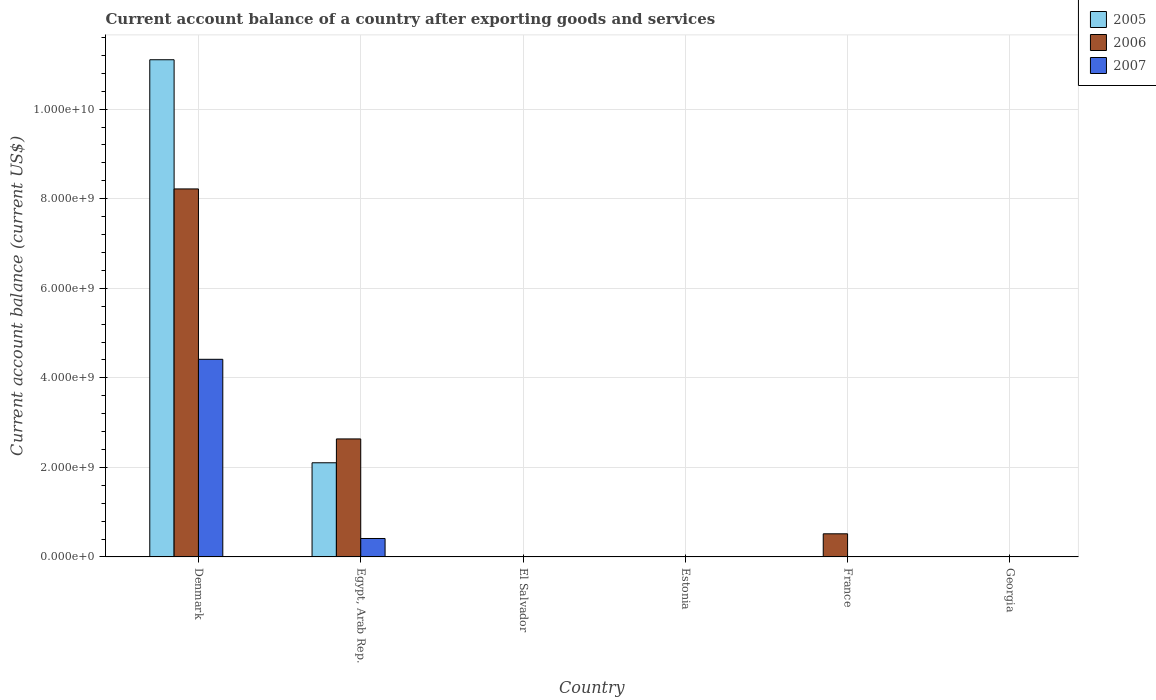What is the label of the 2nd group of bars from the left?
Your answer should be very brief. Egypt, Arab Rep. What is the account balance in 2006 in France?
Offer a terse response. 5.16e+08. Across all countries, what is the maximum account balance in 2007?
Provide a succinct answer. 4.41e+09. What is the total account balance in 2005 in the graph?
Keep it short and to the point. 1.32e+1. What is the difference between the account balance in 2007 in Denmark and that in Egypt, Arab Rep.?
Offer a terse response. 4.00e+09. What is the average account balance in 2007 per country?
Provide a succinct answer. 8.04e+08. What is the difference between the account balance of/in 2006 and account balance of/in 2005 in Denmark?
Offer a very short reply. -2.89e+09. What is the ratio of the account balance in 2005 in Denmark to that in Egypt, Arab Rep.?
Keep it short and to the point. 5.28. What is the difference between the highest and the second highest account balance in 2006?
Your response must be concise. 2.12e+09. What is the difference between the highest and the lowest account balance in 2006?
Your answer should be very brief. 8.22e+09. In how many countries, is the account balance in 2006 greater than the average account balance in 2006 taken over all countries?
Provide a succinct answer. 2. How many bars are there?
Ensure brevity in your answer.  7. Are all the bars in the graph horizontal?
Make the answer very short. No. What is the difference between two consecutive major ticks on the Y-axis?
Ensure brevity in your answer.  2.00e+09. Does the graph contain grids?
Give a very brief answer. Yes. Where does the legend appear in the graph?
Your answer should be very brief. Top right. What is the title of the graph?
Offer a very short reply. Current account balance of a country after exporting goods and services. What is the label or title of the Y-axis?
Your response must be concise. Current account balance (current US$). What is the Current account balance (current US$) in 2005 in Denmark?
Keep it short and to the point. 1.11e+1. What is the Current account balance (current US$) of 2006 in Denmark?
Your response must be concise. 8.22e+09. What is the Current account balance (current US$) in 2007 in Denmark?
Offer a terse response. 4.41e+09. What is the Current account balance (current US$) of 2005 in Egypt, Arab Rep.?
Provide a succinct answer. 2.10e+09. What is the Current account balance (current US$) of 2006 in Egypt, Arab Rep.?
Provide a short and direct response. 2.64e+09. What is the Current account balance (current US$) in 2007 in Egypt, Arab Rep.?
Your answer should be compact. 4.12e+08. What is the Current account balance (current US$) in 2005 in El Salvador?
Offer a terse response. 0. What is the Current account balance (current US$) in 2007 in El Salvador?
Your answer should be very brief. 0. What is the Current account balance (current US$) of 2007 in Estonia?
Your answer should be compact. 0. What is the Current account balance (current US$) of 2005 in France?
Your answer should be compact. 0. What is the Current account balance (current US$) in 2006 in France?
Give a very brief answer. 5.16e+08. What is the Current account balance (current US$) in 2007 in France?
Make the answer very short. 0. What is the Current account balance (current US$) in 2006 in Georgia?
Ensure brevity in your answer.  0. Across all countries, what is the maximum Current account balance (current US$) of 2005?
Your answer should be compact. 1.11e+1. Across all countries, what is the maximum Current account balance (current US$) in 2006?
Your answer should be compact. 8.22e+09. Across all countries, what is the maximum Current account balance (current US$) of 2007?
Ensure brevity in your answer.  4.41e+09. Across all countries, what is the minimum Current account balance (current US$) of 2005?
Your answer should be compact. 0. Across all countries, what is the minimum Current account balance (current US$) of 2006?
Your response must be concise. 0. Across all countries, what is the minimum Current account balance (current US$) of 2007?
Keep it short and to the point. 0. What is the total Current account balance (current US$) of 2005 in the graph?
Provide a short and direct response. 1.32e+1. What is the total Current account balance (current US$) of 2006 in the graph?
Your answer should be very brief. 1.14e+1. What is the total Current account balance (current US$) in 2007 in the graph?
Give a very brief answer. 4.83e+09. What is the difference between the Current account balance (current US$) of 2005 in Denmark and that in Egypt, Arab Rep.?
Give a very brief answer. 9.00e+09. What is the difference between the Current account balance (current US$) of 2006 in Denmark and that in Egypt, Arab Rep.?
Offer a very short reply. 5.58e+09. What is the difference between the Current account balance (current US$) of 2007 in Denmark and that in Egypt, Arab Rep.?
Keep it short and to the point. 4.00e+09. What is the difference between the Current account balance (current US$) of 2006 in Denmark and that in France?
Offer a very short reply. 7.70e+09. What is the difference between the Current account balance (current US$) of 2006 in Egypt, Arab Rep. and that in France?
Ensure brevity in your answer.  2.12e+09. What is the difference between the Current account balance (current US$) of 2005 in Denmark and the Current account balance (current US$) of 2006 in Egypt, Arab Rep.?
Your answer should be very brief. 8.47e+09. What is the difference between the Current account balance (current US$) of 2005 in Denmark and the Current account balance (current US$) of 2007 in Egypt, Arab Rep.?
Offer a terse response. 1.07e+1. What is the difference between the Current account balance (current US$) of 2006 in Denmark and the Current account balance (current US$) of 2007 in Egypt, Arab Rep.?
Your response must be concise. 7.81e+09. What is the difference between the Current account balance (current US$) in 2005 in Denmark and the Current account balance (current US$) in 2006 in France?
Your answer should be very brief. 1.06e+1. What is the difference between the Current account balance (current US$) in 2005 in Egypt, Arab Rep. and the Current account balance (current US$) in 2006 in France?
Offer a terse response. 1.59e+09. What is the average Current account balance (current US$) of 2005 per country?
Provide a short and direct response. 2.20e+09. What is the average Current account balance (current US$) in 2006 per country?
Provide a short and direct response. 1.90e+09. What is the average Current account balance (current US$) in 2007 per country?
Give a very brief answer. 8.04e+08. What is the difference between the Current account balance (current US$) in 2005 and Current account balance (current US$) in 2006 in Denmark?
Offer a very short reply. 2.89e+09. What is the difference between the Current account balance (current US$) of 2005 and Current account balance (current US$) of 2007 in Denmark?
Offer a very short reply. 6.69e+09. What is the difference between the Current account balance (current US$) in 2006 and Current account balance (current US$) in 2007 in Denmark?
Provide a succinct answer. 3.80e+09. What is the difference between the Current account balance (current US$) in 2005 and Current account balance (current US$) in 2006 in Egypt, Arab Rep.?
Keep it short and to the point. -5.33e+08. What is the difference between the Current account balance (current US$) of 2005 and Current account balance (current US$) of 2007 in Egypt, Arab Rep.?
Your answer should be compact. 1.69e+09. What is the difference between the Current account balance (current US$) of 2006 and Current account balance (current US$) of 2007 in Egypt, Arab Rep.?
Your answer should be very brief. 2.22e+09. What is the ratio of the Current account balance (current US$) of 2005 in Denmark to that in Egypt, Arab Rep.?
Your response must be concise. 5.28. What is the ratio of the Current account balance (current US$) in 2006 in Denmark to that in Egypt, Arab Rep.?
Make the answer very short. 3.12. What is the ratio of the Current account balance (current US$) of 2007 in Denmark to that in Egypt, Arab Rep.?
Ensure brevity in your answer.  10.72. What is the ratio of the Current account balance (current US$) in 2006 in Denmark to that in France?
Your answer should be compact. 15.91. What is the ratio of the Current account balance (current US$) of 2006 in Egypt, Arab Rep. to that in France?
Provide a short and direct response. 5.1. What is the difference between the highest and the second highest Current account balance (current US$) in 2006?
Make the answer very short. 5.58e+09. What is the difference between the highest and the lowest Current account balance (current US$) of 2005?
Keep it short and to the point. 1.11e+1. What is the difference between the highest and the lowest Current account balance (current US$) of 2006?
Give a very brief answer. 8.22e+09. What is the difference between the highest and the lowest Current account balance (current US$) in 2007?
Offer a very short reply. 4.41e+09. 